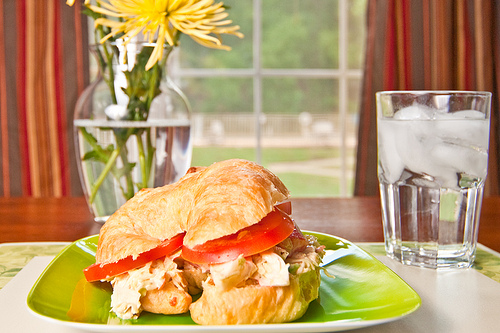Are both the placemat and the table made of the sharegpt4v/same material? No, the placemat and the table are made of different materials. 